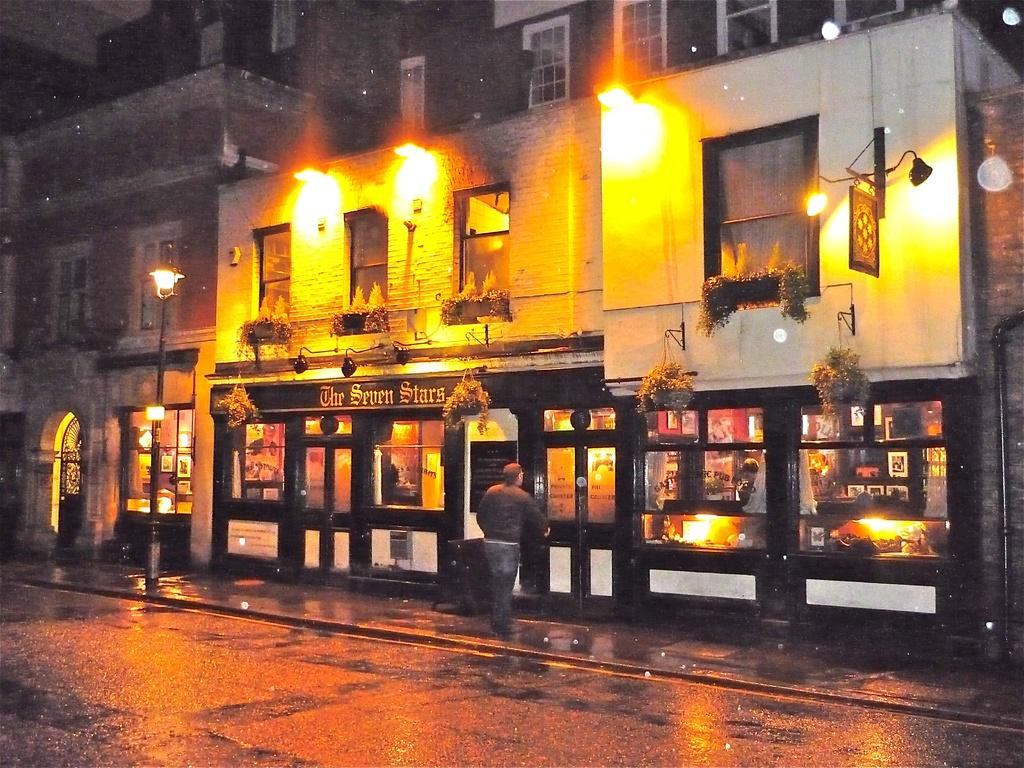What is in the foreground of the image? There is a road in the foreground of the image. What can be seen in the image besides the road? There are lights, buildings, plants, and a man on the side path in the image. Can you describe the buildings in the image? The image shows buildings, but their specific characteristics are not mentioned in the facts. What type of plants are visible in the image? The facts mention that there are plants in the image, but their specific type is not mentioned. What type of coat is the man's brother wearing in the image? There is no mention of a coat or the man's brother in the image, so this information cannot be determined. 